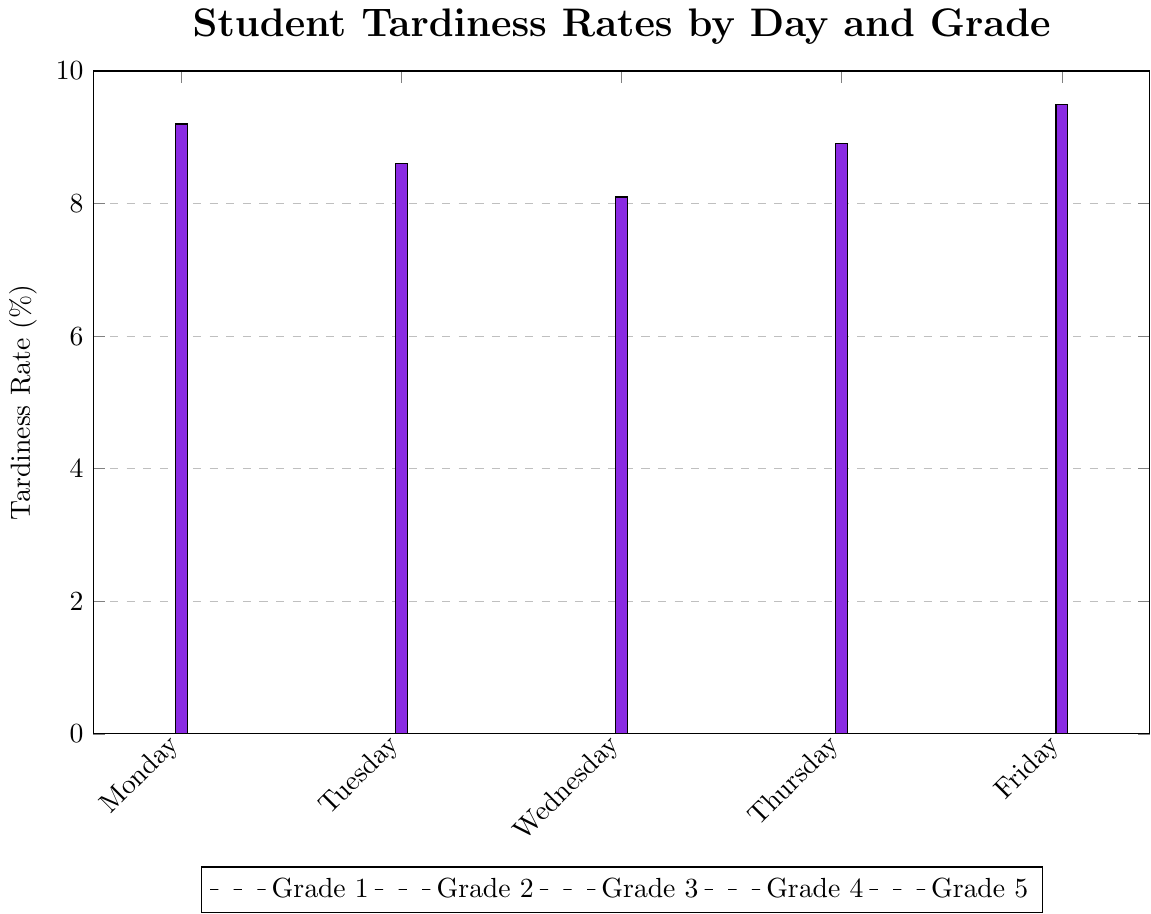Which day shows the highest tardiness rate for Grade 1 students? The highest bar for Grade 1 students (red) appears on Friday with a value of 5.5%.
Answer: Friday For which grade does Monday have the highest tardiness rate? Observing the heights of bars on Monday, Grade 5 (purple) has the tallest bar with a value of 9.2%.
Answer: Grade 5 What is the difference in tardiness rate between Wednesday and Thursday for Grade 3 students? The bar for Grade 3 (green) on Wednesday is 6.4%, and on Thursday, it is 7.1%. The difference is 7.1% - 6.4% = 0.7%.
Answer: 0.7% Which grade consistently shows increasing tardiness rates from Monday to Friday? Examining the bars for each grade from Monday to Friday, Grade 5 (purple) displays a consistent increase from 9.2% to 9.5%.
Answer: Grade 5 What is the average tardiness rate for Grade 4 students over the week? Sum the rates for Grade 4 (blue): 8.5% + 7.8% + 7.2% + 8.0% + 8.8% = 40.3%, then divide by 5. The average is 40.3% / 5 = 8.06%.
Answer: 8.06% What is the combined tardiness rate for Grade 2 and Grade 4 students on Tuesday? Adding the rates for Tuesday for Grade 2 (orange, 5.7%) and Grade 4 (blue, 7.8%): 5.7% + 7.8% = 13.5%.
Answer: 13.5% On which day does Grade 4 have a higher tardiness rate than all other days except one? On Monday, Grade 4 (8.5%) is lower than Thursday (8.0%), both higher than on Tuesday (7.8%), and Wednesday (7.2%), and only lower than on Friday (8.8%). Thus, Thursday is the second-highest.
Answer: Monday Between Grade 1 and Grade 2, which grade has lower tardiness rates on average throughout the week? Sum rates for Grade 1: 5.2% + 4.8% + 4.5% + 4.9% + 5.5% = 24.9%, average = 4.98%. Sum for Grade 2: 6.1% + 5.7% + 5.3% + 5.8% + 6.4% = 29.3%, average = 5.86%. Grade 1 has the lower average rate.
Answer: Grade 1 